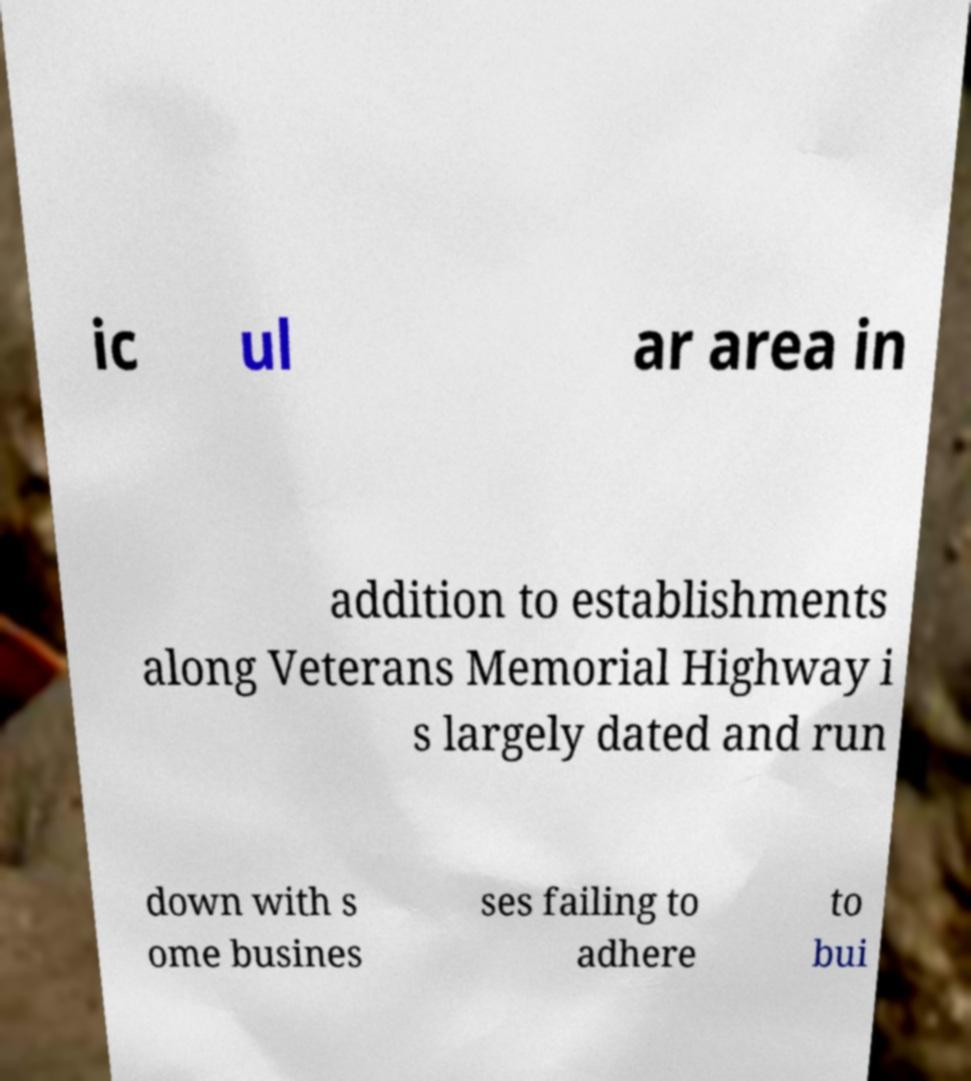I need the written content from this picture converted into text. Can you do that? ic ul ar area in addition to establishments along Veterans Memorial Highway i s largely dated and run down with s ome busines ses failing to adhere to bui 